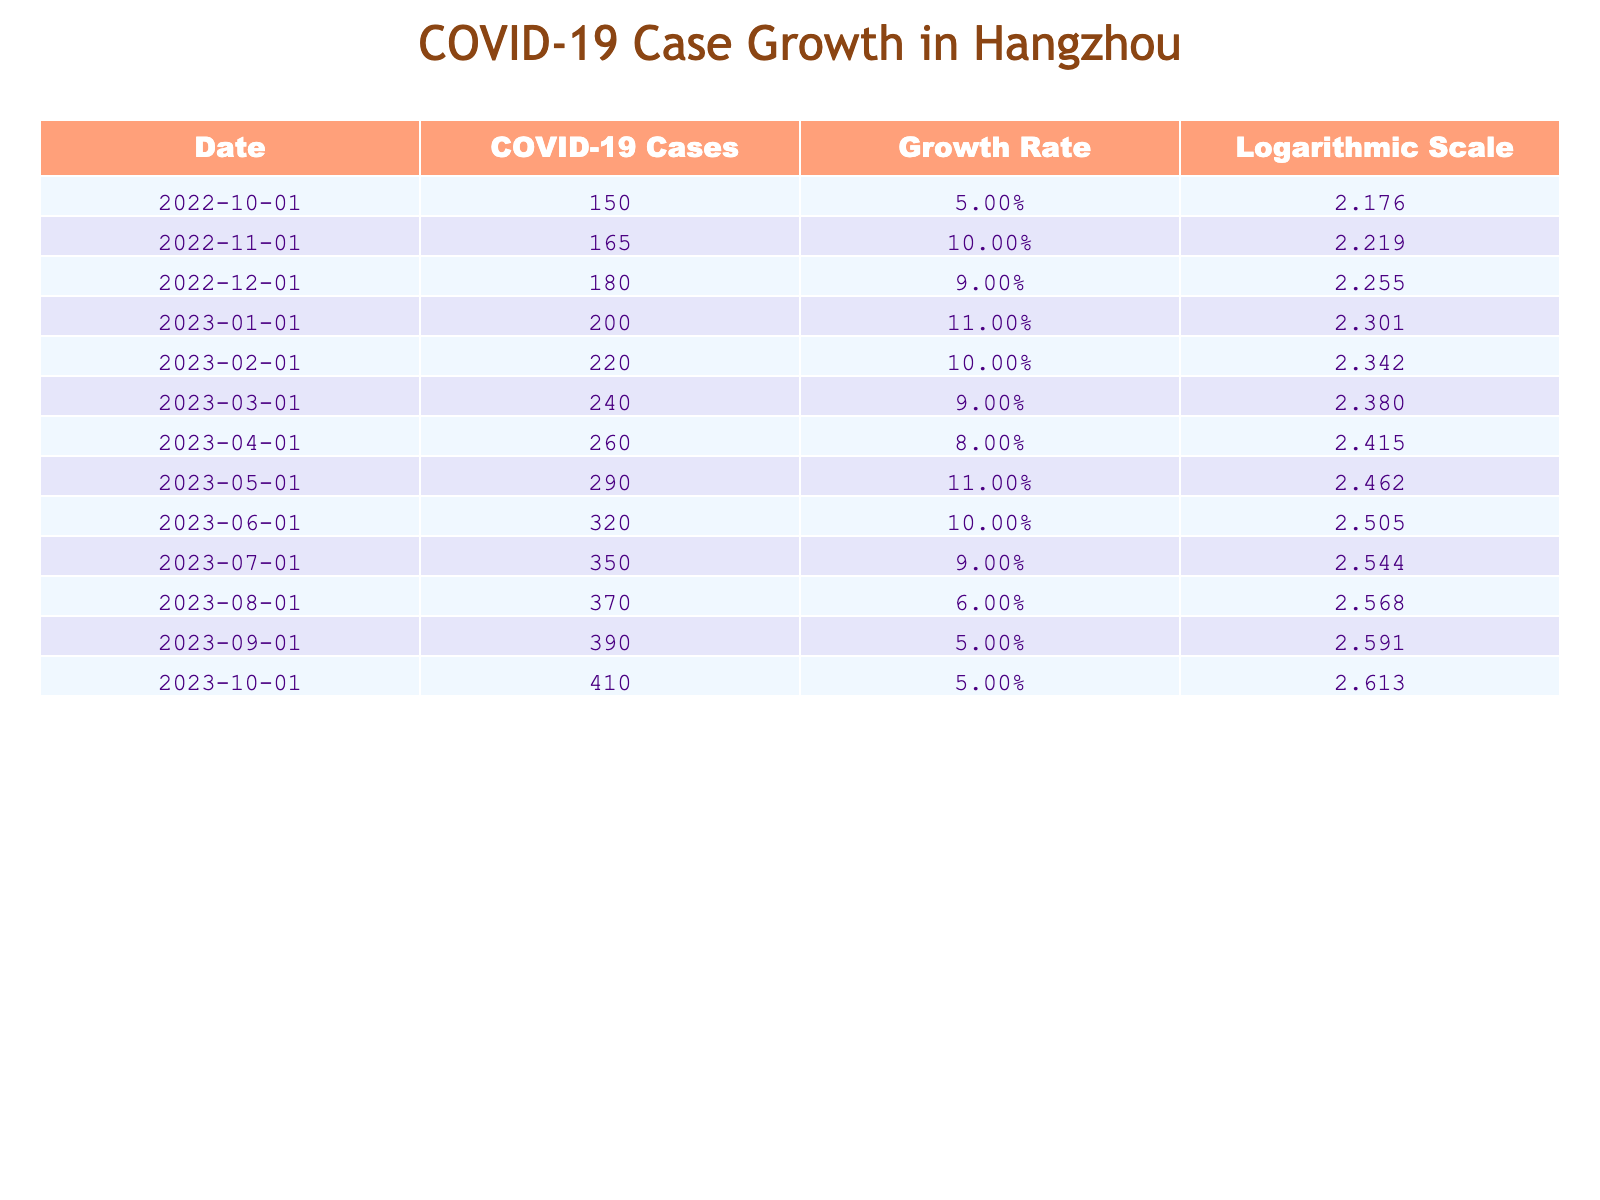What was the COVID-19 case count on February 1, 2023? The table shows that on February 1, 2023, the COVID-19 case count is listed as 220.
Answer: 220 What is the growth rate of COVID-19 cases on October 1, 2022? Referring to the table, the growth rate for October 1, 2022, is stated as 0.05.
Answer: 0.05 Which month recorded the highest number of COVID-19 cases in the past year? By looking at the case counts in the table, the highest recorded number is 410 on October 1, 2023.
Answer: 410 What was the average growth rate from March 2023 to October 2023? The growth rates during this period are 0.09, 0.08, 0.11, 0.1, 0.09, 0.06, and 0.05. There are 7 values; summing them up gives 0.09 + 0.08 + 0.11 + 0.1 + 0.09 + 0.06 + 0.05 = 0.58. The average growth rate is 0.58/7 = approximately 0.083.
Answer: 0.083 Did COVID-19 cases steadily increase every month in Hangzhou over this period? By analyzing the data, while cases generally increased, there were fluctuations in the growth rates, indicating that the increase was not steady.
Answer: No What was the growth rate difference between January 2023 and March 2023? The growth rate in January 2023 is 0.11 and in March 2023 is 0.09. The difference is 0.11 - 0.09 = 0.02.
Answer: 0.02 What is the COVID-19 case count in August 2023? The table lists the COVID-19 case count in August 2023 as 370.
Answer: 370 Was there a consistent trend in growth rates from October 2022 to October 2023? Analyzing the growth rates shows fluctuations rather than a consistent trend.
Answer: No What was the logarithmic value of COVID-19 cases on June 1, 2023? According to the table, the logarithmic value of COVID-19 cases on June 1, 2023, is 2.505.
Answer: 2.505 